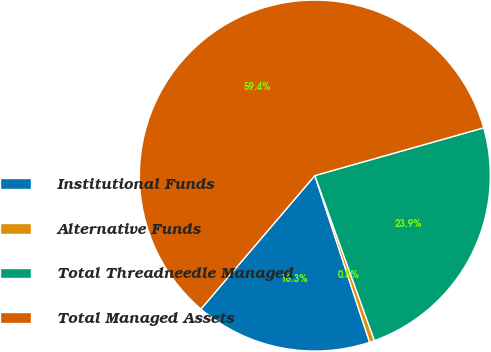Convert chart. <chart><loc_0><loc_0><loc_500><loc_500><pie_chart><fcel>Institutional Funds<fcel>Alternative Funds<fcel>Total Threadneedle Managed<fcel>Total Managed Assets<nl><fcel>16.3%<fcel>0.46%<fcel>23.87%<fcel>59.36%<nl></chart> 